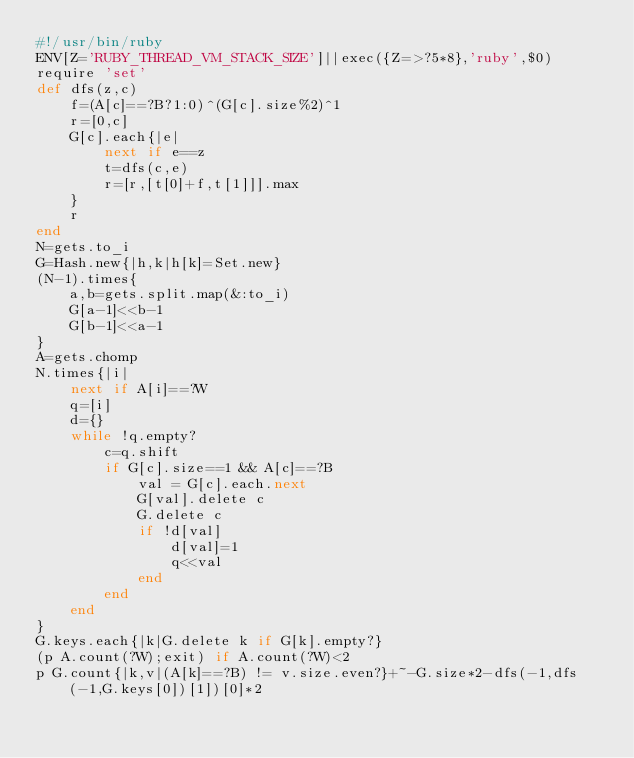Convert code to text. <code><loc_0><loc_0><loc_500><loc_500><_Ruby_>#!/usr/bin/ruby
ENV[Z='RUBY_THREAD_VM_STACK_SIZE']||exec({Z=>?5*8},'ruby',$0)
require 'set'
def dfs(z,c)
	f=(A[c]==?B?1:0)^(G[c].size%2)^1
	r=[0,c]
	G[c].each{|e|
		next if e==z
		t=dfs(c,e)
		r=[r,[t[0]+f,t[1]]].max
	}
	r
end
N=gets.to_i
G=Hash.new{|h,k|h[k]=Set.new}
(N-1).times{
	a,b=gets.split.map(&:to_i)
	G[a-1]<<b-1
	G[b-1]<<a-1
}
A=gets.chomp
N.times{|i|
	next if A[i]==?W
	q=[i]
	d={}
	while !q.empty?
		c=q.shift
		if G[c].size==1 && A[c]==?B
			val = G[c].each.next
			G[val].delete c
			G.delete c
			if !d[val]
				d[val]=1
				q<<val
			end
		end
	end
}
G.keys.each{|k|G.delete k if G[k].empty?}
(p A.count(?W);exit) if A.count(?W)<2
p G.count{|k,v|(A[k]==?B) != v.size.even?}+~-G.size*2-dfs(-1,dfs(-1,G.keys[0])[1])[0]*2
</code> 